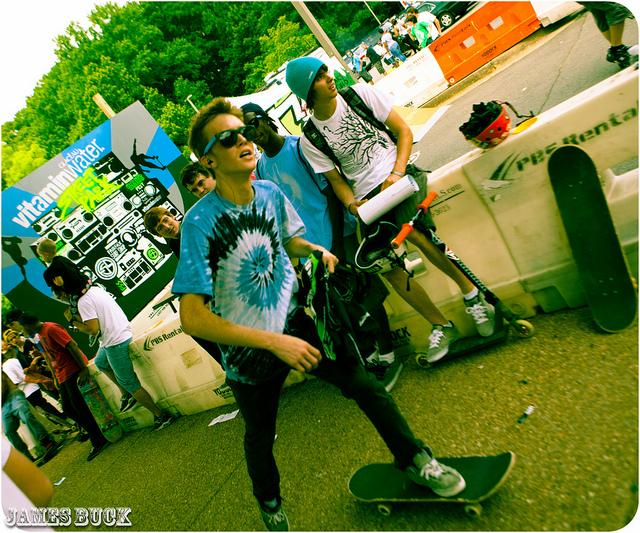What type of event is happening here?

Choices:
A) rodeo
B) dog show
C) movie
D) skateboard expo skateboard expo 